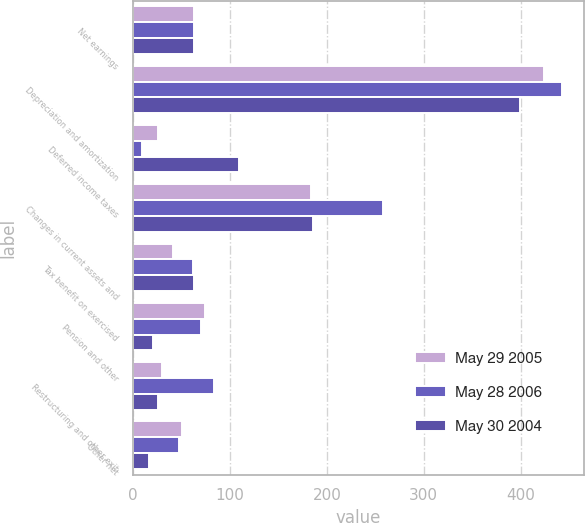<chart> <loc_0><loc_0><loc_500><loc_500><stacked_bar_chart><ecel><fcel>Net earnings<fcel>Depreciation and amortization<fcel>Deferred income taxes<fcel>Changes in current assets and<fcel>Tax benefit on exercised<fcel>Pension and other<fcel>Restructuring and other exit<fcel>Other net<nl><fcel>May 29 2005<fcel>63<fcel>424<fcel>26<fcel>184<fcel>41<fcel>74<fcel>30<fcel>50<nl><fcel>May 28 2006<fcel>63<fcel>443<fcel>9<fcel>258<fcel>62<fcel>70<fcel>84<fcel>47<nl><fcel>May 30 2004<fcel>63<fcel>399<fcel>109<fcel>186<fcel>63<fcel>21<fcel>26<fcel>16<nl></chart> 